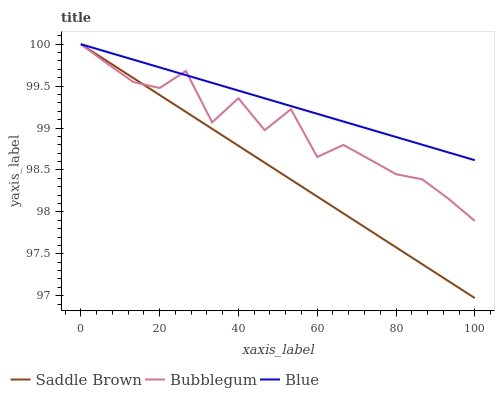Does Saddle Brown have the minimum area under the curve?
Answer yes or no. Yes. Does Blue have the maximum area under the curve?
Answer yes or no. Yes. Does Bubblegum have the minimum area under the curve?
Answer yes or no. No. Does Bubblegum have the maximum area under the curve?
Answer yes or no. No. Is Saddle Brown the smoothest?
Answer yes or no. Yes. Is Bubblegum the roughest?
Answer yes or no. Yes. Is Bubblegum the smoothest?
Answer yes or no. No. Is Saddle Brown the roughest?
Answer yes or no. No. Does Saddle Brown have the lowest value?
Answer yes or no. Yes. Does Bubblegum have the lowest value?
Answer yes or no. No. Does Bubblegum have the highest value?
Answer yes or no. Yes. Does Bubblegum intersect Saddle Brown?
Answer yes or no. Yes. Is Bubblegum less than Saddle Brown?
Answer yes or no. No. Is Bubblegum greater than Saddle Brown?
Answer yes or no. No. 